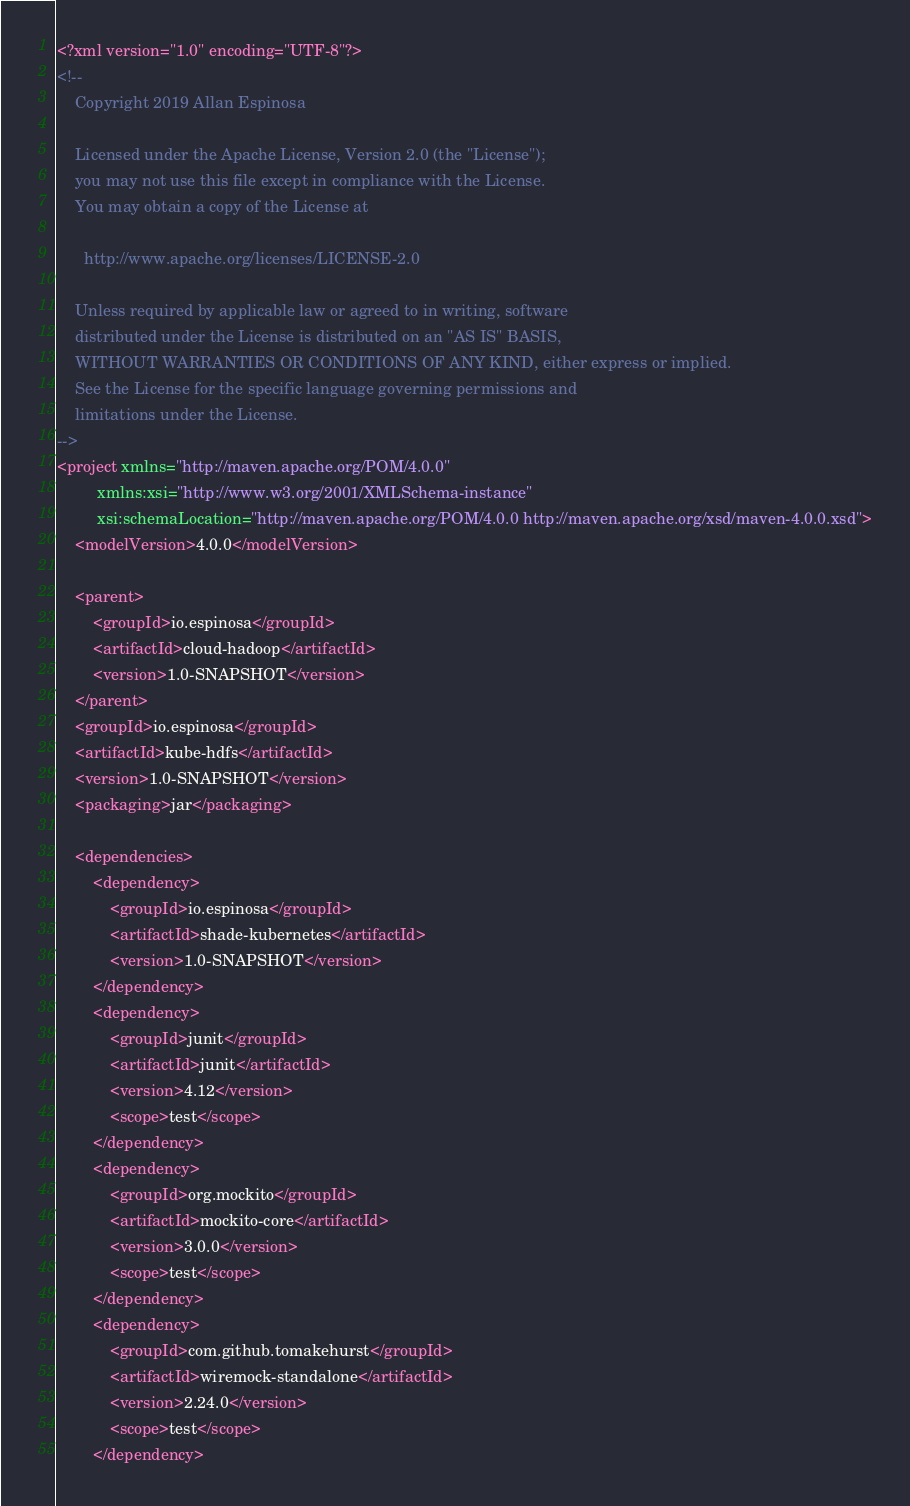<code> <loc_0><loc_0><loc_500><loc_500><_XML_><?xml version="1.0" encoding="UTF-8"?>
<!--
    Copyright 2019 Allan Espinosa

    Licensed under the Apache License, Version 2.0 (the "License");
    you may not use this file except in compliance with the License.
    You may obtain a copy of the License at

      http://www.apache.org/licenses/LICENSE-2.0

    Unless required by applicable law or agreed to in writing, software
    distributed under the License is distributed on an "AS IS" BASIS,
    WITHOUT WARRANTIES OR CONDITIONS OF ANY KIND, either express or implied.
    See the License for the specific language governing permissions and
    limitations under the License.
-->
<project xmlns="http://maven.apache.org/POM/4.0.0"
         xmlns:xsi="http://www.w3.org/2001/XMLSchema-instance"
         xsi:schemaLocation="http://maven.apache.org/POM/4.0.0 http://maven.apache.org/xsd/maven-4.0.0.xsd">
    <modelVersion>4.0.0</modelVersion>

    <parent>
        <groupId>io.espinosa</groupId>
        <artifactId>cloud-hadoop</artifactId>
        <version>1.0-SNAPSHOT</version>
    </parent>
    <groupId>io.espinosa</groupId>
    <artifactId>kube-hdfs</artifactId>
    <version>1.0-SNAPSHOT</version>
    <packaging>jar</packaging>

    <dependencies>
        <dependency>
            <groupId>io.espinosa</groupId>
            <artifactId>shade-kubernetes</artifactId>
            <version>1.0-SNAPSHOT</version>
        </dependency>
        <dependency>
            <groupId>junit</groupId>
            <artifactId>junit</artifactId>
            <version>4.12</version>
            <scope>test</scope>
        </dependency>
        <dependency>
            <groupId>org.mockito</groupId>
            <artifactId>mockito-core</artifactId>
            <version>3.0.0</version>
            <scope>test</scope>
        </dependency>
        <dependency>
            <groupId>com.github.tomakehurst</groupId>
            <artifactId>wiremock-standalone</artifactId>
            <version>2.24.0</version>
            <scope>test</scope>
        </dependency></code> 